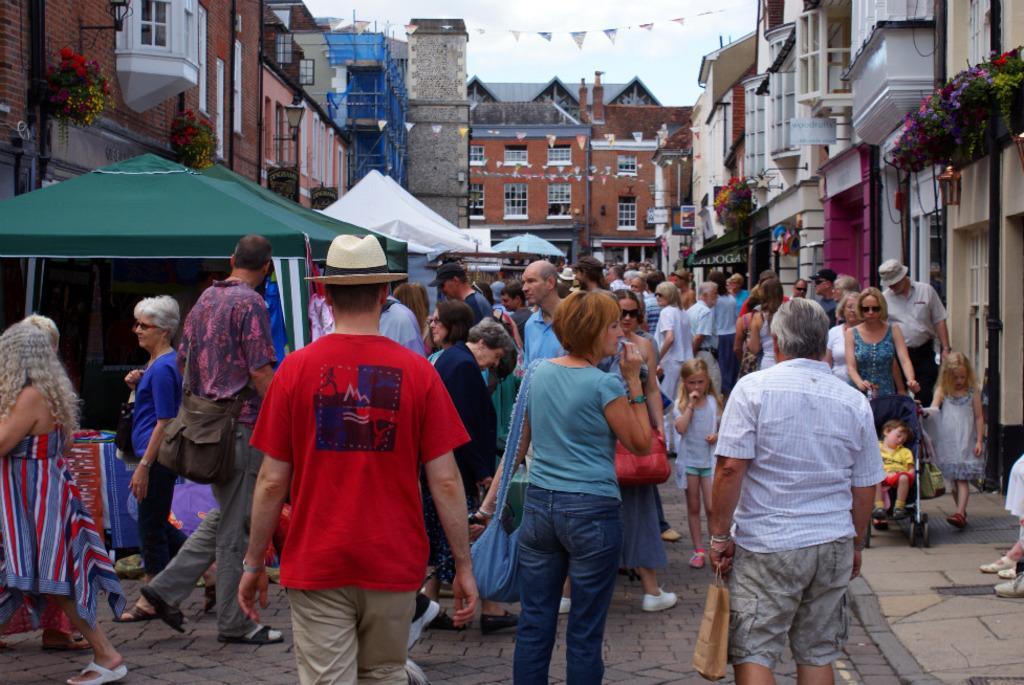Please provide a concise description of this image. This picture is clicked outside. In the center we can see the group of people seems to be walking on the ground. On the left we can see the tents. In the background there is a sky and the buildings and we can see the flowers and some boards on which the text is printed. 